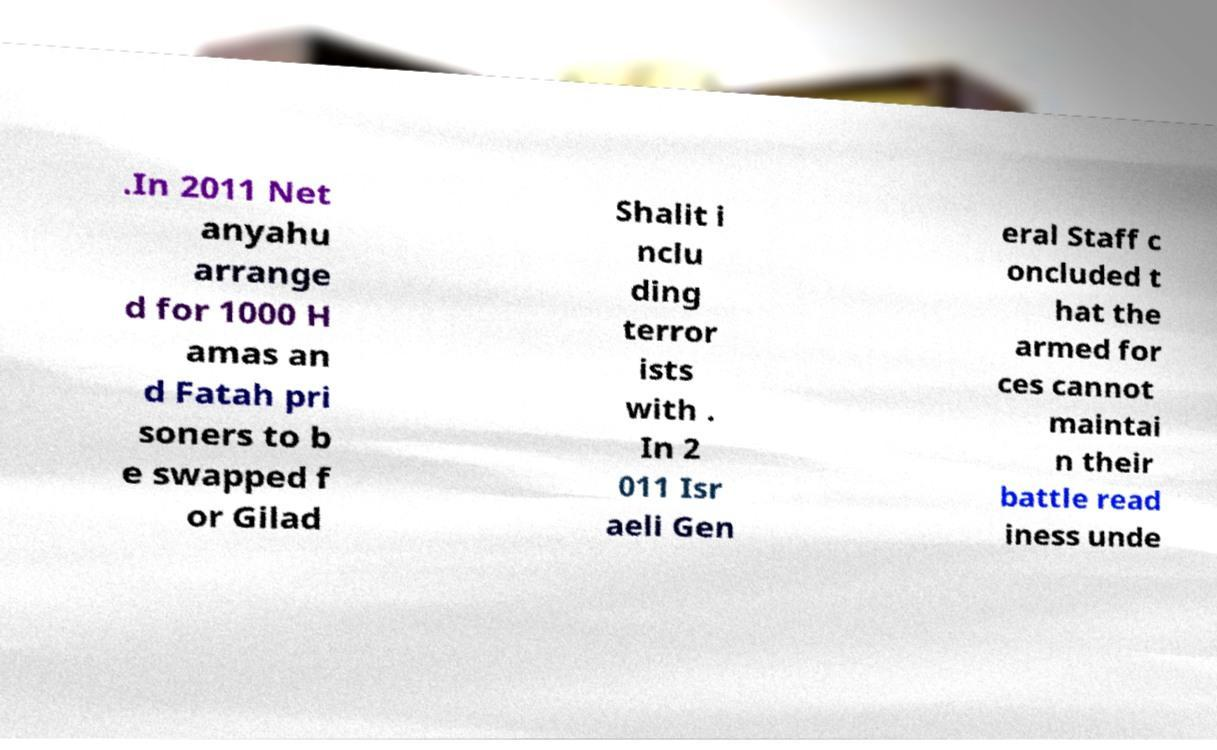There's text embedded in this image that I need extracted. Can you transcribe it verbatim? .In 2011 Net anyahu arrange d for 1000 H amas an d Fatah pri soners to b e swapped f or Gilad Shalit i nclu ding terror ists with . In 2 011 Isr aeli Gen eral Staff c oncluded t hat the armed for ces cannot maintai n their battle read iness unde 